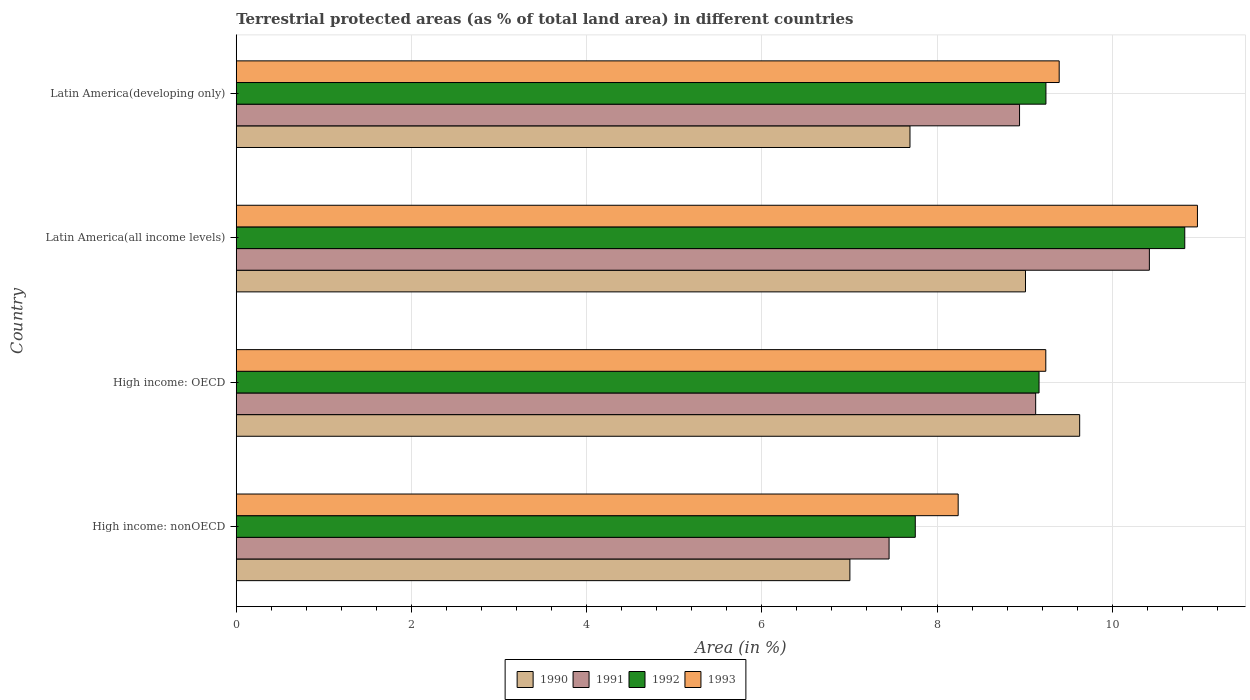How many different coloured bars are there?
Offer a terse response. 4. How many groups of bars are there?
Provide a short and direct response. 4. How many bars are there on the 4th tick from the top?
Offer a terse response. 4. What is the label of the 3rd group of bars from the top?
Offer a terse response. High income: OECD. What is the percentage of terrestrial protected land in 1990 in High income: nonOECD?
Make the answer very short. 7.01. Across all countries, what is the maximum percentage of terrestrial protected land in 1990?
Give a very brief answer. 9.63. Across all countries, what is the minimum percentage of terrestrial protected land in 1991?
Offer a terse response. 7.45. In which country was the percentage of terrestrial protected land in 1990 maximum?
Ensure brevity in your answer.  High income: OECD. In which country was the percentage of terrestrial protected land in 1991 minimum?
Ensure brevity in your answer.  High income: nonOECD. What is the total percentage of terrestrial protected land in 1993 in the graph?
Make the answer very short. 37.85. What is the difference between the percentage of terrestrial protected land in 1990 in High income: OECD and that in Latin America(all income levels)?
Make the answer very short. 0.62. What is the difference between the percentage of terrestrial protected land in 1991 in Latin America(developing only) and the percentage of terrestrial protected land in 1993 in High income: nonOECD?
Make the answer very short. 0.7. What is the average percentage of terrestrial protected land in 1993 per country?
Keep it short and to the point. 9.46. What is the difference between the percentage of terrestrial protected land in 1993 and percentage of terrestrial protected land in 1992 in High income: nonOECD?
Ensure brevity in your answer.  0.49. In how many countries, is the percentage of terrestrial protected land in 1992 greater than 1.2000000000000002 %?
Ensure brevity in your answer.  4. What is the ratio of the percentage of terrestrial protected land in 1990 in High income: nonOECD to that in Latin America(developing only)?
Your answer should be very brief. 0.91. What is the difference between the highest and the second highest percentage of terrestrial protected land in 1992?
Give a very brief answer. 1.58. What is the difference between the highest and the lowest percentage of terrestrial protected land in 1991?
Provide a short and direct response. 2.97. Is the sum of the percentage of terrestrial protected land in 1991 in Latin America(all income levels) and Latin America(developing only) greater than the maximum percentage of terrestrial protected land in 1990 across all countries?
Keep it short and to the point. Yes. What does the 2nd bar from the top in High income: nonOECD represents?
Provide a short and direct response. 1992. What does the 1st bar from the bottom in Latin America(all income levels) represents?
Make the answer very short. 1990. Is it the case that in every country, the sum of the percentage of terrestrial protected land in 1990 and percentage of terrestrial protected land in 1991 is greater than the percentage of terrestrial protected land in 1992?
Make the answer very short. Yes. Does the graph contain any zero values?
Provide a short and direct response. No. Does the graph contain grids?
Your answer should be compact. Yes. How many legend labels are there?
Provide a short and direct response. 4. What is the title of the graph?
Provide a succinct answer. Terrestrial protected areas (as % of total land area) in different countries. What is the label or title of the X-axis?
Your answer should be compact. Area (in %). What is the label or title of the Y-axis?
Offer a terse response. Country. What is the Area (in %) in 1990 in High income: nonOECD?
Give a very brief answer. 7.01. What is the Area (in %) in 1991 in High income: nonOECD?
Make the answer very short. 7.45. What is the Area (in %) in 1992 in High income: nonOECD?
Ensure brevity in your answer.  7.75. What is the Area (in %) of 1993 in High income: nonOECD?
Give a very brief answer. 8.24. What is the Area (in %) of 1990 in High income: OECD?
Give a very brief answer. 9.63. What is the Area (in %) of 1991 in High income: OECD?
Ensure brevity in your answer.  9.13. What is the Area (in %) of 1992 in High income: OECD?
Provide a succinct answer. 9.16. What is the Area (in %) of 1993 in High income: OECD?
Keep it short and to the point. 9.24. What is the Area (in %) in 1990 in Latin America(all income levels)?
Your response must be concise. 9.01. What is the Area (in %) of 1991 in Latin America(all income levels)?
Keep it short and to the point. 10.42. What is the Area (in %) in 1992 in Latin America(all income levels)?
Provide a succinct answer. 10.83. What is the Area (in %) of 1993 in Latin America(all income levels)?
Ensure brevity in your answer.  10.97. What is the Area (in %) in 1990 in Latin America(developing only)?
Make the answer very short. 7.69. What is the Area (in %) of 1991 in Latin America(developing only)?
Offer a terse response. 8.94. What is the Area (in %) in 1992 in Latin America(developing only)?
Give a very brief answer. 9.24. What is the Area (in %) of 1993 in Latin America(developing only)?
Ensure brevity in your answer.  9.39. Across all countries, what is the maximum Area (in %) in 1990?
Offer a terse response. 9.63. Across all countries, what is the maximum Area (in %) in 1991?
Ensure brevity in your answer.  10.42. Across all countries, what is the maximum Area (in %) of 1992?
Provide a succinct answer. 10.83. Across all countries, what is the maximum Area (in %) of 1993?
Provide a short and direct response. 10.97. Across all countries, what is the minimum Area (in %) in 1990?
Make the answer very short. 7.01. Across all countries, what is the minimum Area (in %) in 1991?
Your answer should be very brief. 7.45. Across all countries, what is the minimum Area (in %) in 1992?
Provide a succinct answer. 7.75. Across all countries, what is the minimum Area (in %) of 1993?
Provide a succinct answer. 8.24. What is the total Area (in %) in 1990 in the graph?
Offer a terse response. 33.34. What is the total Area (in %) of 1991 in the graph?
Make the answer very short. 35.95. What is the total Area (in %) of 1992 in the graph?
Offer a terse response. 36.99. What is the total Area (in %) of 1993 in the graph?
Your answer should be compact. 37.85. What is the difference between the Area (in %) in 1990 in High income: nonOECD and that in High income: OECD?
Provide a succinct answer. -2.62. What is the difference between the Area (in %) in 1991 in High income: nonOECD and that in High income: OECD?
Offer a terse response. -1.67. What is the difference between the Area (in %) in 1992 in High income: nonOECD and that in High income: OECD?
Offer a terse response. -1.41. What is the difference between the Area (in %) in 1993 in High income: nonOECD and that in High income: OECD?
Your response must be concise. -1. What is the difference between the Area (in %) in 1990 in High income: nonOECD and that in Latin America(all income levels)?
Provide a succinct answer. -2. What is the difference between the Area (in %) in 1991 in High income: nonOECD and that in Latin America(all income levels)?
Make the answer very short. -2.97. What is the difference between the Area (in %) in 1992 in High income: nonOECD and that in Latin America(all income levels)?
Make the answer very short. -3.08. What is the difference between the Area (in %) of 1993 in High income: nonOECD and that in Latin America(all income levels)?
Give a very brief answer. -2.73. What is the difference between the Area (in %) in 1990 in High income: nonOECD and that in Latin America(developing only)?
Offer a very short reply. -0.69. What is the difference between the Area (in %) in 1991 in High income: nonOECD and that in Latin America(developing only)?
Provide a short and direct response. -1.49. What is the difference between the Area (in %) in 1992 in High income: nonOECD and that in Latin America(developing only)?
Give a very brief answer. -1.49. What is the difference between the Area (in %) in 1993 in High income: nonOECD and that in Latin America(developing only)?
Ensure brevity in your answer.  -1.15. What is the difference between the Area (in %) of 1990 in High income: OECD and that in Latin America(all income levels)?
Keep it short and to the point. 0.62. What is the difference between the Area (in %) in 1991 in High income: OECD and that in Latin America(all income levels)?
Make the answer very short. -1.3. What is the difference between the Area (in %) of 1992 in High income: OECD and that in Latin America(all income levels)?
Offer a very short reply. -1.66. What is the difference between the Area (in %) in 1993 in High income: OECD and that in Latin America(all income levels)?
Make the answer very short. -1.73. What is the difference between the Area (in %) of 1990 in High income: OECD and that in Latin America(developing only)?
Your answer should be compact. 1.94. What is the difference between the Area (in %) in 1991 in High income: OECD and that in Latin America(developing only)?
Offer a terse response. 0.18. What is the difference between the Area (in %) of 1992 in High income: OECD and that in Latin America(developing only)?
Keep it short and to the point. -0.08. What is the difference between the Area (in %) in 1993 in High income: OECD and that in Latin America(developing only)?
Ensure brevity in your answer.  -0.15. What is the difference between the Area (in %) of 1990 in Latin America(all income levels) and that in Latin America(developing only)?
Make the answer very short. 1.32. What is the difference between the Area (in %) of 1991 in Latin America(all income levels) and that in Latin America(developing only)?
Offer a very short reply. 1.48. What is the difference between the Area (in %) in 1992 in Latin America(all income levels) and that in Latin America(developing only)?
Your answer should be very brief. 1.58. What is the difference between the Area (in %) in 1993 in Latin America(all income levels) and that in Latin America(developing only)?
Provide a short and direct response. 1.58. What is the difference between the Area (in %) of 1990 in High income: nonOECD and the Area (in %) of 1991 in High income: OECD?
Your answer should be very brief. -2.12. What is the difference between the Area (in %) in 1990 in High income: nonOECD and the Area (in %) in 1992 in High income: OECD?
Provide a succinct answer. -2.16. What is the difference between the Area (in %) in 1990 in High income: nonOECD and the Area (in %) in 1993 in High income: OECD?
Keep it short and to the point. -2.24. What is the difference between the Area (in %) of 1991 in High income: nonOECD and the Area (in %) of 1992 in High income: OECD?
Your answer should be very brief. -1.71. What is the difference between the Area (in %) of 1991 in High income: nonOECD and the Area (in %) of 1993 in High income: OECD?
Make the answer very short. -1.79. What is the difference between the Area (in %) of 1992 in High income: nonOECD and the Area (in %) of 1993 in High income: OECD?
Your answer should be compact. -1.49. What is the difference between the Area (in %) of 1990 in High income: nonOECD and the Area (in %) of 1991 in Latin America(all income levels)?
Your answer should be compact. -3.42. What is the difference between the Area (in %) in 1990 in High income: nonOECD and the Area (in %) in 1992 in Latin America(all income levels)?
Give a very brief answer. -3.82. What is the difference between the Area (in %) of 1990 in High income: nonOECD and the Area (in %) of 1993 in Latin America(all income levels)?
Make the answer very short. -3.97. What is the difference between the Area (in %) in 1991 in High income: nonOECD and the Area (in %) in 1992 in Latin America(all income levels)?
Ensure brevity in your answer.  -3.38. What is the difference between the Area (in %) in 1991 in High income: nonOECD and the Area (in %) in 1993 in Latin America(all income levels)?
Offer a very short reply. -3.52. What is the difference between the Area (in %) of 1992 in High income: nonOECD and the Area (in %) of 1993 in Latin America(all income levels)?
Offer a very short reply. -3.22. What is the difference between the Area (in %) in 1990 in High income: nonOECD and the Area (in %) in 1991 in Latin America(developing only)?
Your response must be concise. -1.94. What is the difference between the Area (in %) in 1990 in High income: nonOECD and the Area (in %) in 1992 in Latin America(developing only)?
Offer a terse response. -2.24. What is the difference between the Area (in %) of 1990 in High income: nonOECD and the Area (in %) of 1993 in Latin America(developing only)?
Your answer should be very brief. -2.39. What is the difference between the Area (in %) of 1991 in High income: nonOECD and the Area (in %) of 1992 in Latin America(developing only)?
Your response must be concise. -1.79. What is the difference between the Area (in %) of 1991 in High income: nonOECD and the Area (in %) of 1993 in Latin America(developing only)?
Offer a terse response. -1.94. What is the difference between the Area (in %) in 1992 in High income: nonOECD and the Area (in %) in 1993 in Latin America(developing only)?
Your response must be concise. -1.64. What is the difference between the Area (in %) of 1990 in High income: OECD and the Area (in %) of 1991 in Latin America(all income levels)?
Your response must be concise. -0.8. What is the difference between the Area (in %) of 1990 in High income: OECD and the Area (in %) of 1992 in Latin America(all income levels)?
Your response must be concise. -1.2. What is the difference between the Area (in %) of 1990 in High income: OECD and the Area (in %) of 1993 in Latin America(all income levels)?
Provide a short and direct response. -1.34. What is the difference between the Area (in %) of 1991 in High income: OECD and the Area (in %) of 1992 in Latin America(all income levels)?
Make the answer very short. -1.7. What is the difference between the Area (in %) of 1991 in High income: OECD and the Area (in %) of 1993 in Latin America(all income levels)?
Your response must be concise. -1.85. What is the difference between the Area (in %) of 1992 in High income: OECD and the Area (in %) of 1993 in Latin America(all income levels)?
Ensure brevity in your answer.  -1.81. What is the difference between the Area (in %) of 1990 in High income: OECD and the Area (in %) of 1991 in Latin America(developing only)?
Your answer should be very brief. 0.69. What is the difference between the Area (in %) of 1990 in High income: OECD and the Area (in %) of 1992 in Latin America(developing only)?
Keep it short and to the point. 0.39. What is the difference between the Area (in %) in 1990 in High income: OECD and the Area (in %) in 1993 in Latin America(developing only)?
Offer a very short reply. 0.23. What is the difference between the Area (in %) in 1991 in High income: OECD and the Area (in %) in 1992 in Latin America(developing only)?
Your answer should be compact. -0.12. What is the difference between the Area (in %) of 1991 in High income: OECD and the Area (in %) of 1993 in Latin America(developing only)?
Make the answer very short. -0.27. What is the difference between the Area (in %) in 1992 in High income: OECD and the Area (in %) in 1993 in Latin America(developing only)?
Your answer should be compact. -0.23. What is the difference between the Area (in %) of 1990 in Latin America(all income levels) and the Area (in %) of 1991 in Latin America(developing only)?
Give a very brief answer. 0.07. What is the difference between the Area (in %) of 1990 in Latin America(all income levels) and the Area (in %) of 1992 in Latin America(developing only)?
Provide a succinct answer. -0.23. What is the difference between the Area (in %) in 1990 in Latin America(all income levels) and the Area (in %) in 1993 in Latin America(developing only)?
Keep it short and to the point. -0.38. What is the difference between the Area (in %) of 1991 in Latin America(all income levels) and the Area (in %) of 1992 in Latin America(developing only)?
Make the answer very short. 1.18. What is the difference between the Area (in %) in 1991 in Latin America(all income levels) and the Area (in %) in 1993 in Latin America(developing only)?
Make the answer very short. 1.03. What is the difference between the Area (in %) in 1992 in Latin America(all income levels) and the Area (in %) in 1993 in Latin America(developing only)?
Offer a very short reply. 1.43. What is the average Area (in %) in 1990 per country?
Provide a short and direct response. 8.33. What is the average Area (in %) in 1991 per country?
Your response must be concise. 8.99. What is the average Area (in %) in 1992 per country?
Keep it short and to the point. 9.25. What is the average Area (in %) of 1993 per country?
Your answer should be very brief. 9.46. What is the difference between the Area (in %) of 1990 and Area (in %) of 1991 in High income: nonOECD?
Make the answer very short. -0.45. What is the difference between the Area (in %) in 1990 and Area (in %) in 1992 in High income: nonOECD?
Ensure brevity in your answer.  -0.75. What is the difference between the Area (in %) of 1990 and Area (in %) of 1993 in High income: nonOECD?
Offer a terse response. -1.24. What is the difference between the Area (in %) in 1991 and Area (in %) in 1992 in High income: nonOECD?
Provide a short and direct response. -0.3. What is the difference between the Area (in %) of 1991 and Area (in %) of 1993 in High income: nonOECD?
Keep it short and to the point. -0.79. What is the difference between the Area (in %) of 1992 and Area (in %) of 1993 in High income: nonOECD?
Give a very brief answer. -0.49. What is the difference between the Area (in %) in 1990 and Area (in %) in 1991 in High income: OECD?
Give a very brief answer. 0.5. What is the difference between the Area (in %) in 1990 and Area (in %) in 1992 in High income: OECD?
Provide a short and direct response. 0.46. What is the difference between the Area (in %) in 1990 and Area (in %) in 1993 in High income: OECD?
Your answer should be very brief. 0.39. What is the difference between the Area (in %) of 1991 and Area (in %) of 1992 in High income: OECD?
Ensure brevity in your answer.  -0.04. What is the difference between the Area (in %) in 1991 and Area (in %) in 1993 in High income: OECD?
Make the answer very short. -0.12. What is the difference between the Area (in %) in 1992 and Area (in %) in 1993 in High income: OECD?
Keep it short and to the point. -0.08. What is the difference between the Area (in %) of 1990 and Area (in %) of 1991 in Latin America(all income levels)?
Your answer should be compact. -1.41. What is the difference between the Area (in %) in 1990 and Area (in %) in 1992 in Latin America(all income levels)?
Offer a terse response. -1.82. What is the difference between the Area (in %) in 1990 and Area (in %) in 1993 in Latin America(all income levels)?
Ensure brevity in your answer.  -1.96. What is the difference between the Area (in %) in 1991 and Area (in %) in 1992 in Latin America(all income levels)?
Keep it short and to the point. -0.4. What is the difference between the Area (in %) of 1991 and Area (in %) of 1993 in Latin America(all income levels)?
Your answer should be very brief. -0.55. What is the difference between the Area (in %) of 1992 and Area (in %) of 1993 in Latin America(all income levels)?
Offer a very short reply. -0.14. What is the difference between the Area (in %) in 1990 and Area (in %) in 1991 in Latin America(developing only)?
Offer a terse response. -1.25. What is the difference between the Area (in %) of 1990 and Area (in %) of 1992 in Latin America(developing only)?
Give a very brief answer. -1.55. What is the difference between the Area (in %) in 1990 and Area (in %) in 1993 in Latin America(developing only)?
Provide a succinct answer. -1.7. What is the difference between the Area (in %) of 1991 and Area (in %) of 1992 in Latin America(developing only)?
Offer a terse response. -0.3. What is the difference between the Area (in %) in 1991 and Area (in %) in 1993 in Latin America(developing only)?
Make the answer very short. -0.45. What is the difference between the Area (in %) of 1992 and Area (in %) of 1993 in Latin America(developing only)?
Make the answer very short. -0.15. What is the ratio of the Area (in %) of 1990 in High income: nonOECD to that in High income: OECD?
Your answer should be very brief. 0.73. What is the ratio of the Area (in %) in 1991 in High income: nonOECD to that in High income: OECD?
Ensure brevity in your answer.  0.82. What is the ratio of the Area (in %) in 1992 in High income: nonOECD to that in High income: OECD?
Offer a terse response. 0.85. What is the ratio of the Area (in %) in 1993 in High income: nonOECD to that in High income: OECD?
Keep it short and to the point. 0.89. What is the ratio of the Area (in %) in 1990 in High income: nonOECD to that in Latin America(all income levels)?
Keep it short and to the point. 0.78. What is the ratio of the Area (in %) in 1991 in High income: nonOECD to that in Latin America(all income levels)?
Provide a short and direct response. 0.71. What is the ratio of the Area (in %) of 1992 in High income: nonOECD to that in Latin America(all income levels)?
Ensure brevity in your answer.  0.72. What is the ratio of the Area (in %) of 1993 in High income: nonOECD to that in Latin America(all income levels)?
Offer a very short reply. 0.75. What is the ratio of the Area (in %) of 1990 in High income: nonOECD to that in Latin America(developing only)?
Provide a succinct answer. 0.91. What is the ratio of the Area (in %) in 1991 in High income: nonOECD to that in Latin America(developing only)?
Your answer should be very brief. 0.83. What is the ratio of the Area (in %) of 1992 in High income: nonOECD to that in Latin America(developing only)?
Ensure brevity in your answer.  0.84. What is the ratio of the Area (in %) of 1993 in High income: nonOECD to that in Latin America(developing only)?
Offer a very short reply. 0.88. What is the ratio of the Area (in %) in 1990 in High income: OECD to that in Latin America(all income levels)?
Offer a very short reply. 1.07. What is the ratio of the Area (in %) of 1991 in High income: OECD to that in Latin America(all income levels)?
Provide a short and direct response. 0.88. What is the ratio of the Area (in %) in 1992 in High income: OECD to that in Latin America(all income levels)?
Ensure brevity in your answer.  0.85. What is the ratio of the Area (in %) in 1993 in High income: OECD to that in Latin America(all income levels)?
Your answer should be compact. 0.84. What is the ratio of the Area (in %) in 1990 in High income: OECD to that in Latin America(developing only)?
Your answer should be very brief. 1.25. What is the ratio of the Area (in %) in 1991 in High income: OECD to that in Latin America(developing only)?
Your response must be concise. 1.02. What is the ratio of the Area (in %) of 1993 in High income: OECD to that in Latin America(developing only)?
Ensure brevity in your answer.  0.98. What is the ratio of the Area (in %) of 1990 in Latin America(all income levels) to that in Latin America(developing only)?
Keep it short and to the point. 1.17. What is the ratio of the Area (in %) of 1991 in Latin America(all income levels) to that in Latin America(developing only)?
Provide a short and direct response. 1.17. What is the ratio of the Area (in %) in 1992 in Latin America(all income levels) to that in Latin America(developing only)?
Your response must be concise. 1.17. What is the ratio of the Area (in %) of 1993 in Latin America(all income levels) to that in Latin America(developing only)?
Offer a very short reply. 1.17. What is the difference between the highest and the second highest Area (in %) of 1990?
Provide a succinct answer. 0.62. What is the difference between the highest and the second highest Area (in %) of 1991?
Keep it short and to the point. 1.3. What is the difference between the highest and the second highest Area (in %) of 1992?
Your response must be concise. 1.58. What is the difference between the highest and the second highest Area (in %) in 1993?
Provide a succinct answer. 1.58. What is the difference between the highest and the lowest Area (in %) of 1990?
Provide a succinct answer. 2.62. What is the difference between the highest and the lowest Area (in %) in 1991?
Your answer should be very brief. 2.97. What is the difference between the highest and the lowest Area (in %) in 1992?
Provide a succinct answer. 3.08. What is the difference between the highest and the lowest Area (in %) of 1993?
Give a very brief answer. 2.73. 